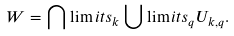Convert formula to latex. <formula><loc_0><loc_0><loc_500><loc_500>W = \bigcap \lim i t s _ { k } \bigcup \lim i t s _ { q } U _ { k , q } .</formula> 